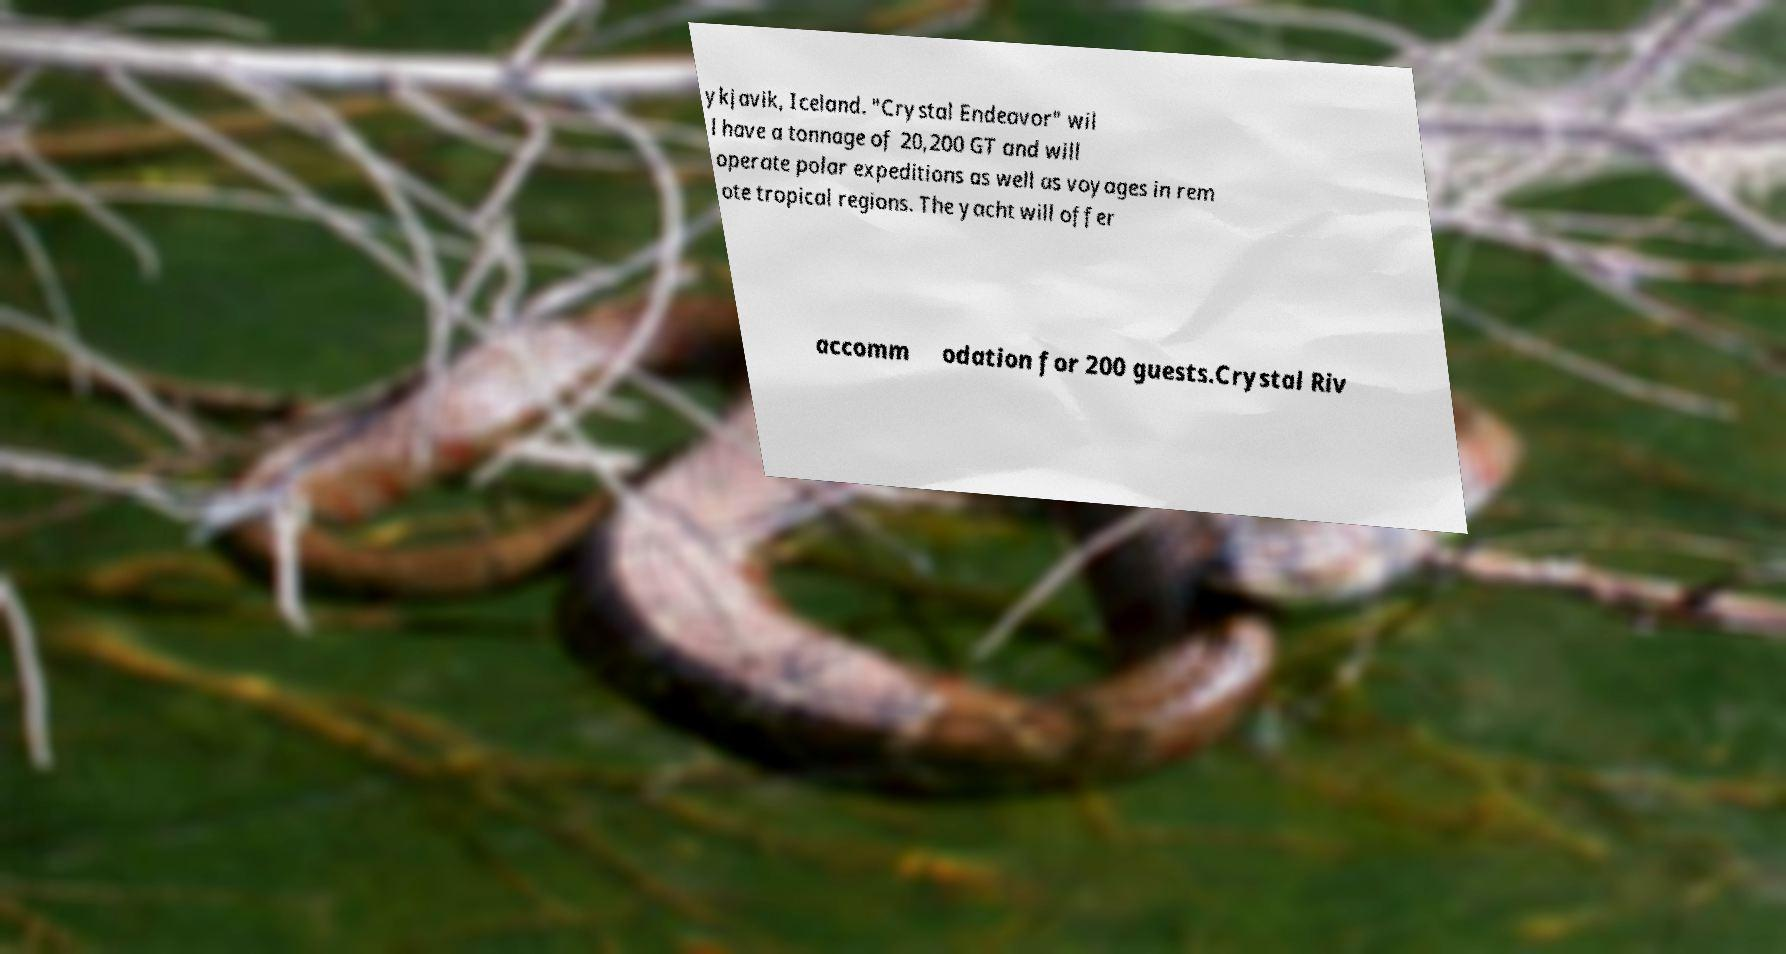Can you read and provide the text displayed in the image?This photo seems to have some interesting text. Can you extract and type it out for me? ykjavik, Iceland. "Crystal Endeavor" wil l have a tonnage of 20,200 GT and will operate polar expeditions as well as voyages in rem ote tropical regions. The yacht will offer accomm odation for 200 guests.Crystal Riv 